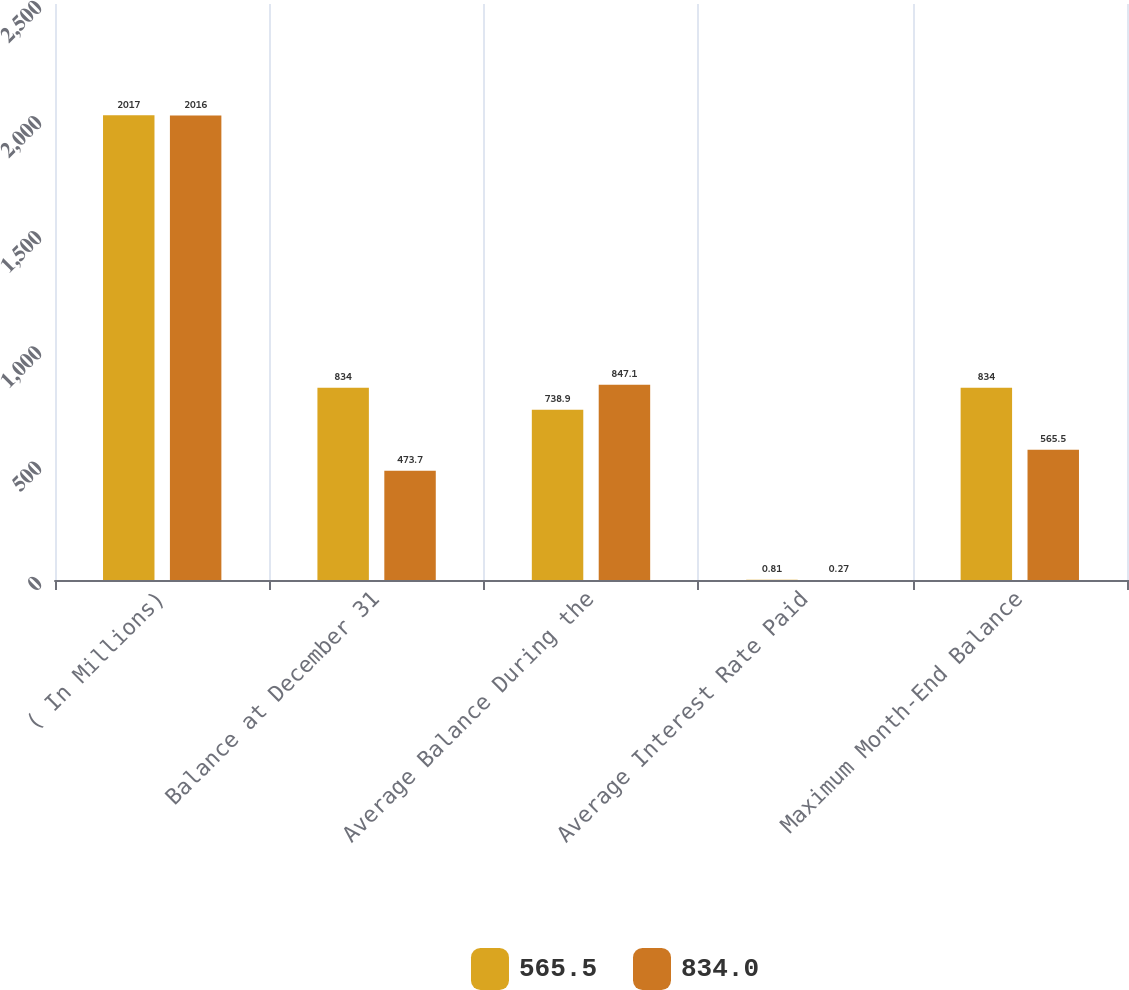Convert chart to OTSL. <chart><loc_0><loc_0><loc_500><loc_500><stacked_bar_chart><ecel><fcel>( In Millions)<fcel>Balance at December 31<fcel>Average Balance During the<fcel>Average Interest Rate Paid<fcel>Maximum Month-End Balance<nl><fcel>565.5<fcel>2017<fcel>834<fcel>738.9<fcel>0.81<fcel>834<nl><fcel>834<fcel>2016<fcel>473.7<fcel>847.1<fcel>0.27<fcel>565.5<nl></chart> 